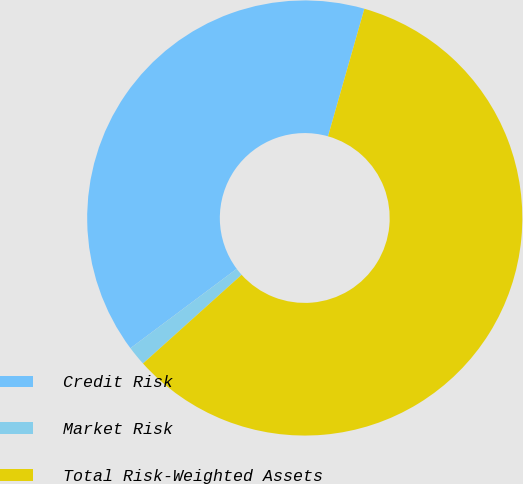Convert chart. <chart><loc_0><loc_0><loc_500><loc_500><pie_chart><fcel>Credit Risk<fcel>Market Risk<fcel>Total Risk-Weighted Assets<nl><fcel>39.63%<fcel>1.45%<fcel>58.92%<nl></chart> 